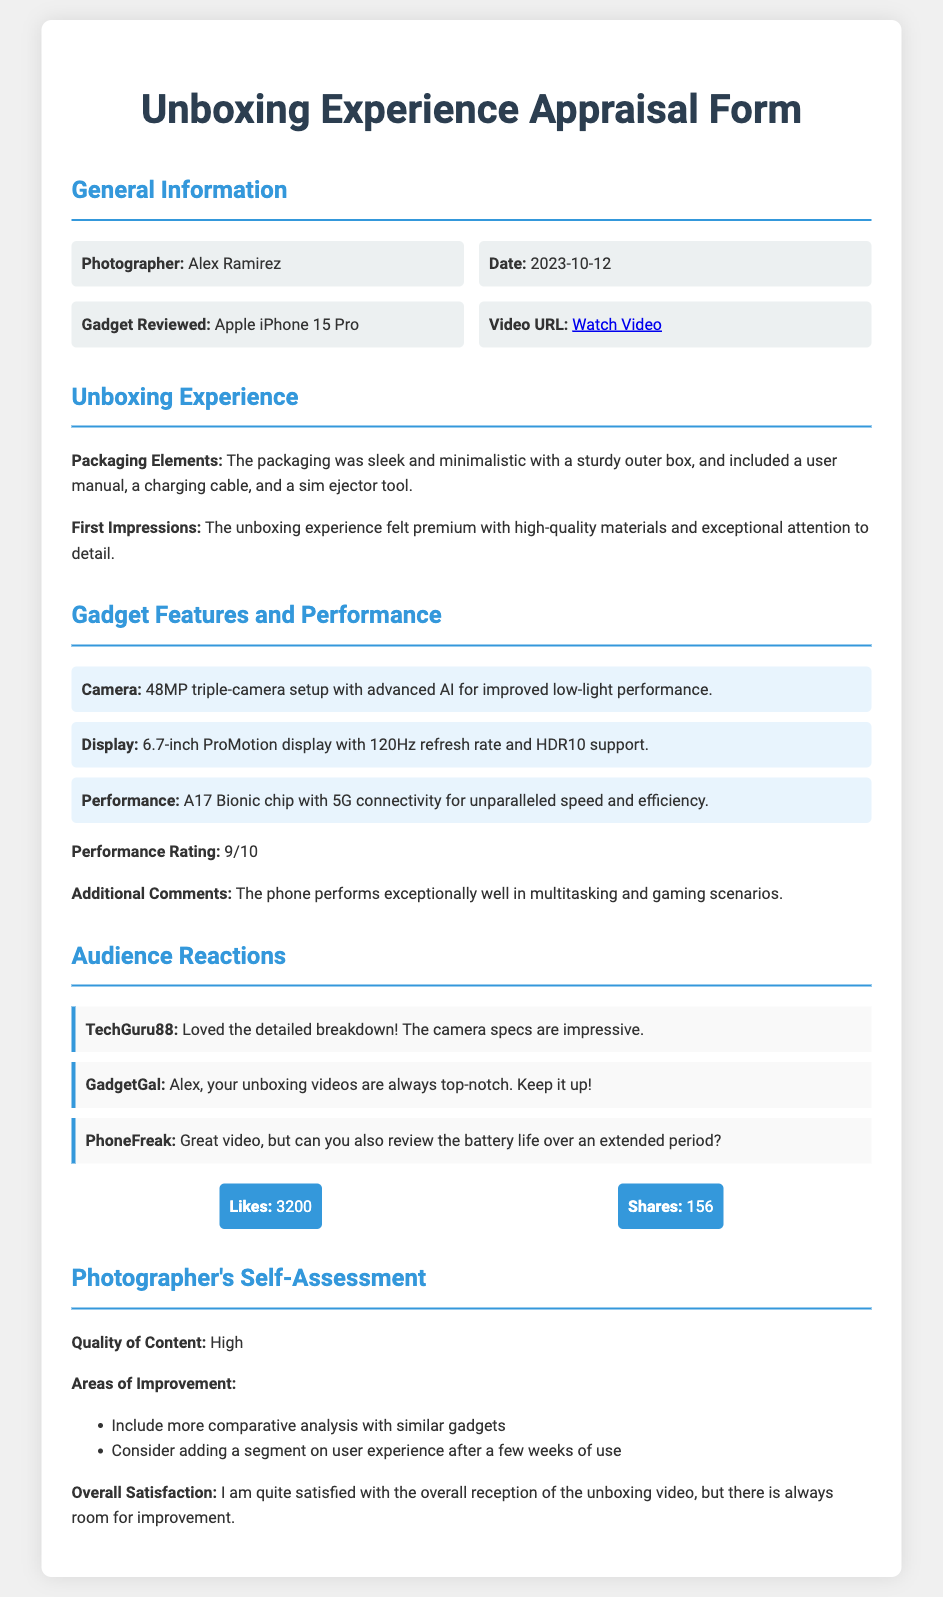What is the photographer's name? The photographer's name is mentioned under the General Information section of the document.
Answer: Alex Ramirez What date was the unboxing video published? The date of the unboxing video is provided in the General Information section.
Answer: 2023-10-12 What gadget was reviewed? The gadget reviewed is specified in the General Information section of the document.
Answer: Apple iPhone 15 Pro What rating did the performance receive? The performance rating is stated explicitly in the Gadget Features and Performance section.
Answer: 9/10 How many likes did the video receive? The number of likes is listed in the Audience Reactions section of the document.
Answer: 3200 What is one area of improvement mentioned for the content? Areas of improvement are listed in the Photographer's Self-Assessment section, where specific suggestions are provided.
Answer: Include more comparative analysis with similar gadgets What feature enhances the phone's low-light performance? This information is included in the Gadget Features and Performance section where camera specifications are discussed.
Answer: Advanced AI What comment was made by TechGuru88? The comment from TechGuru88 is included under the Audience Reactions section.
Answer: Loved the detailed breakdown! The camera specs are impressive 